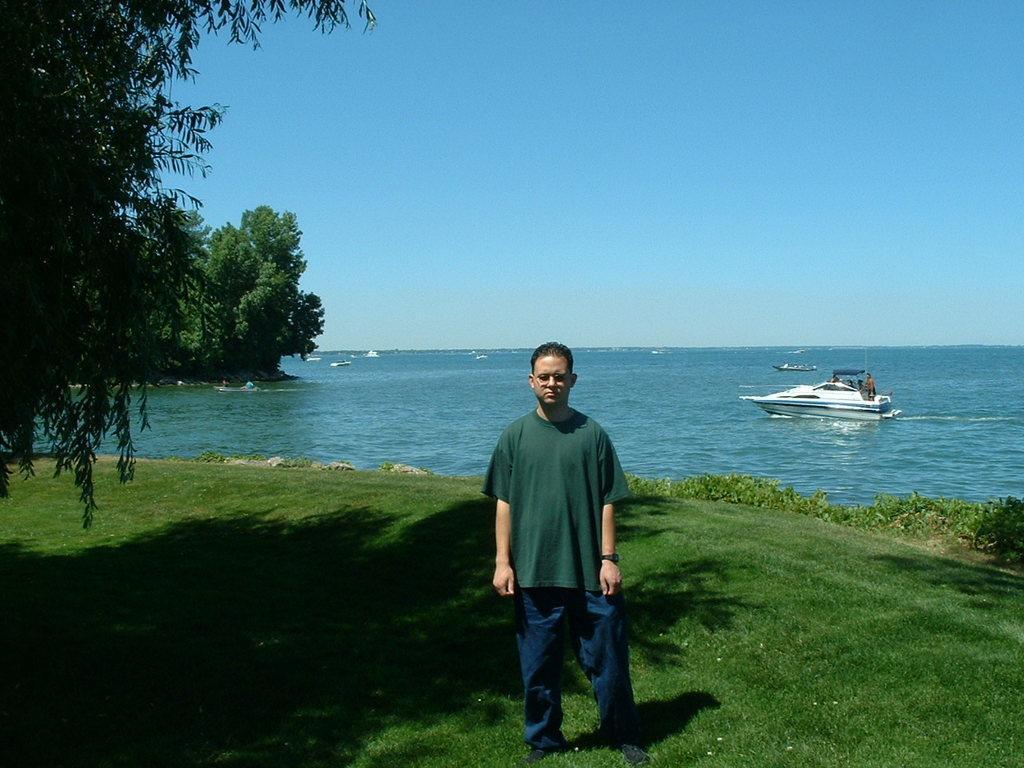How would you summarize this image in a sentence or two? In this image there is a person standing on the surface of the grass. On the left side of the image there are trees. In the background there are few boats on the river and the sky. 